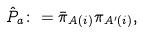Convert formula to latex. <formula><loc_0><loc_0><loc_500><loc_500>\hat { P } _ { a } \colon = \bar { \pi } _ { A ( i ) } \pi _ { A ^ { \prime } ( i ) } ,</formula> 